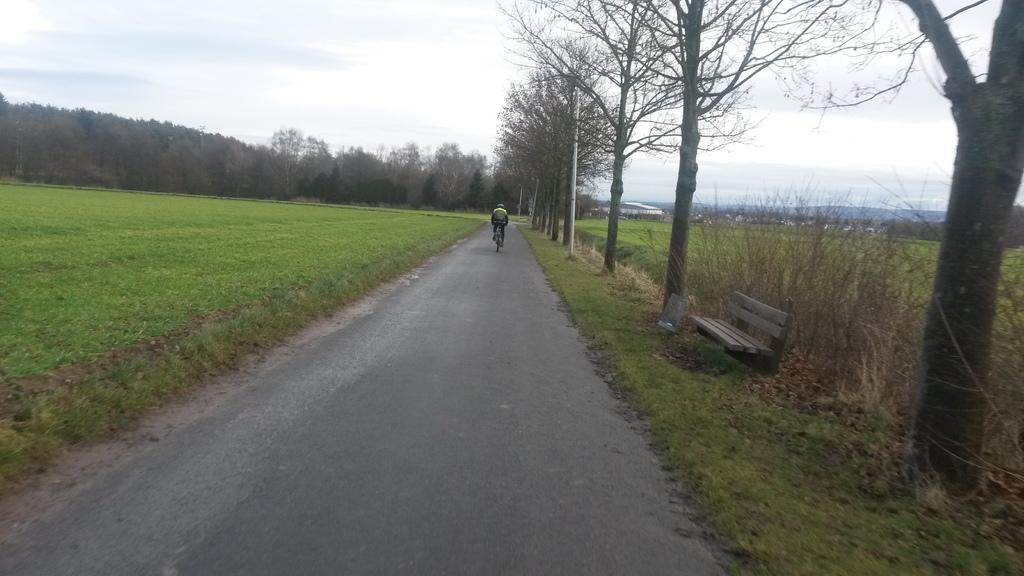What is the main subject of the image? There is a person in the image. What is the person doing in the image? The person is riding a bicycle. What can be seen in the background of the image? There are trees and the sky visible in the background of the image. What type of fruit is the person holding while riding the bicycle in the image? There is no fruit visible in the image; the person is riding a bicycle without holding any fruit. 